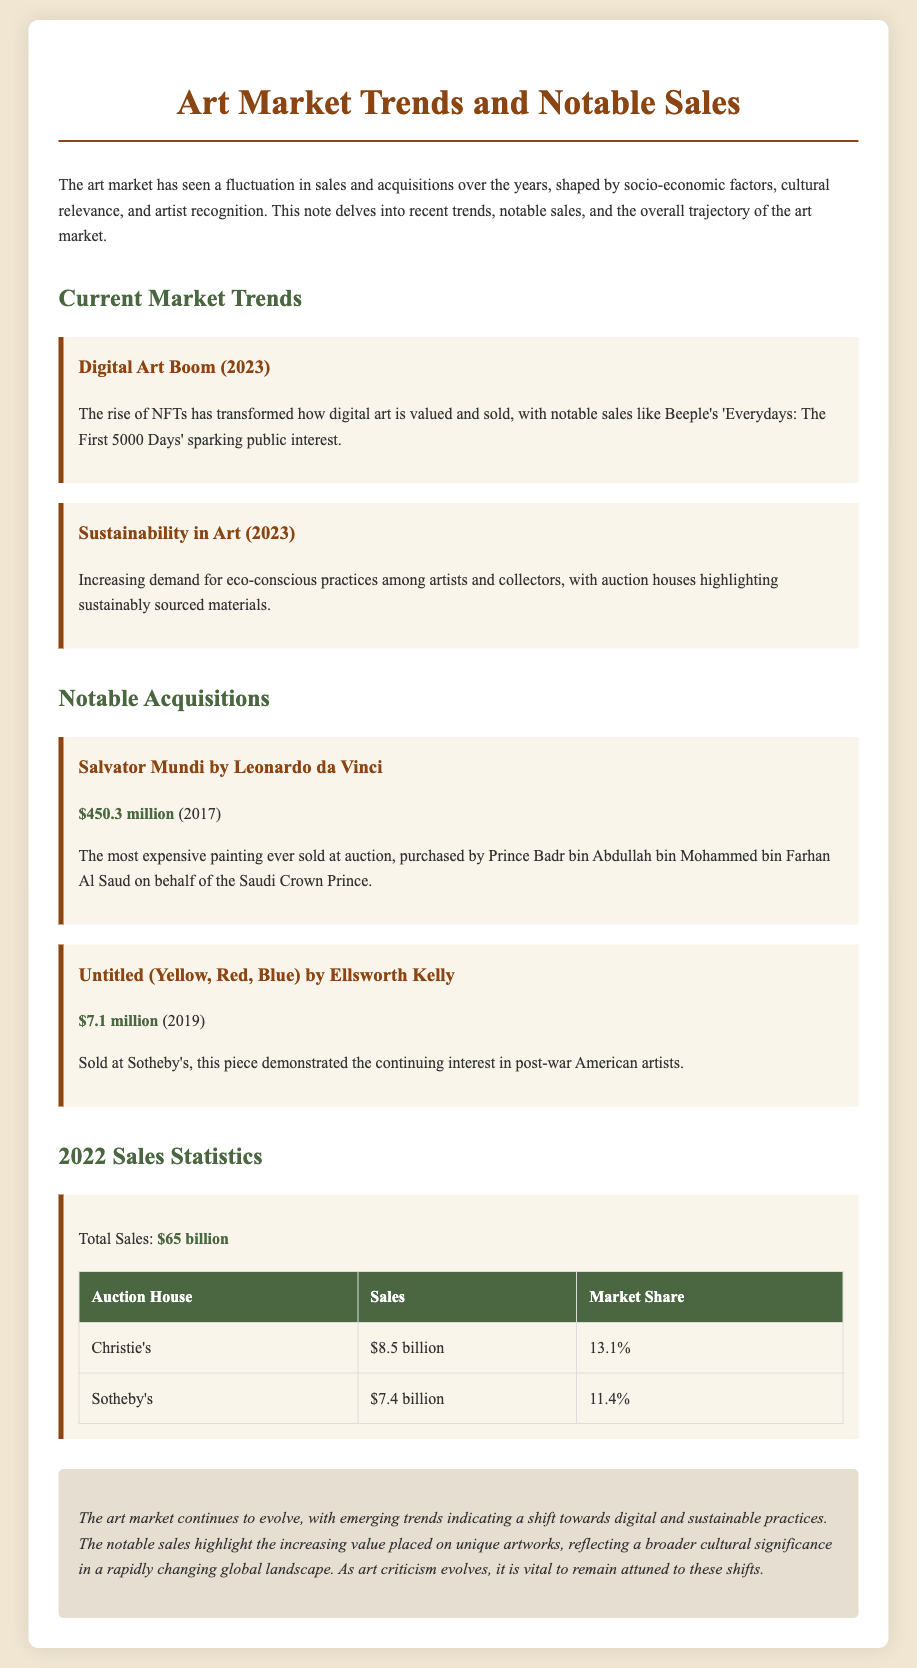What is the title of the document? The title is stated at the top of the document, summarizing its content.
Answer: Art Market Trends and Notable Sales What was the total sales in 2022? The total sales figure is mentioned in the statistics section of the document.
Answer: $65 billion Who purchased Salvator Mundi? The document names the individual responsible for the purchase in its discussion of notable acquisitions.
Answer: Prince Badr bin Abdullah bin Mohammed bin Farhan Al Saud What year was Untitled (Yellow, Red, Blue) sold? The document specifies the year associated with the sale of the artwork.
Answer: 2019 What market share did Sotheby's have in 2022? The market share of Sotheby's is detailed in the sales statistics table.
Answer: 11.4% What was a key trend in 2023 related to art? The document mentions trends that are currently shaping the art market in 2023.
Answer: Digital Art Boom How much was Salvator Mundi sold for? The document gives a specific price in relation to the notable acquisition discussed.
Answer: $450.3 million What is emphasized about materials in recent art trends? The document highlights the importance of eco-conscious practices in the art market.
Answer: Sustainably sourced materials 